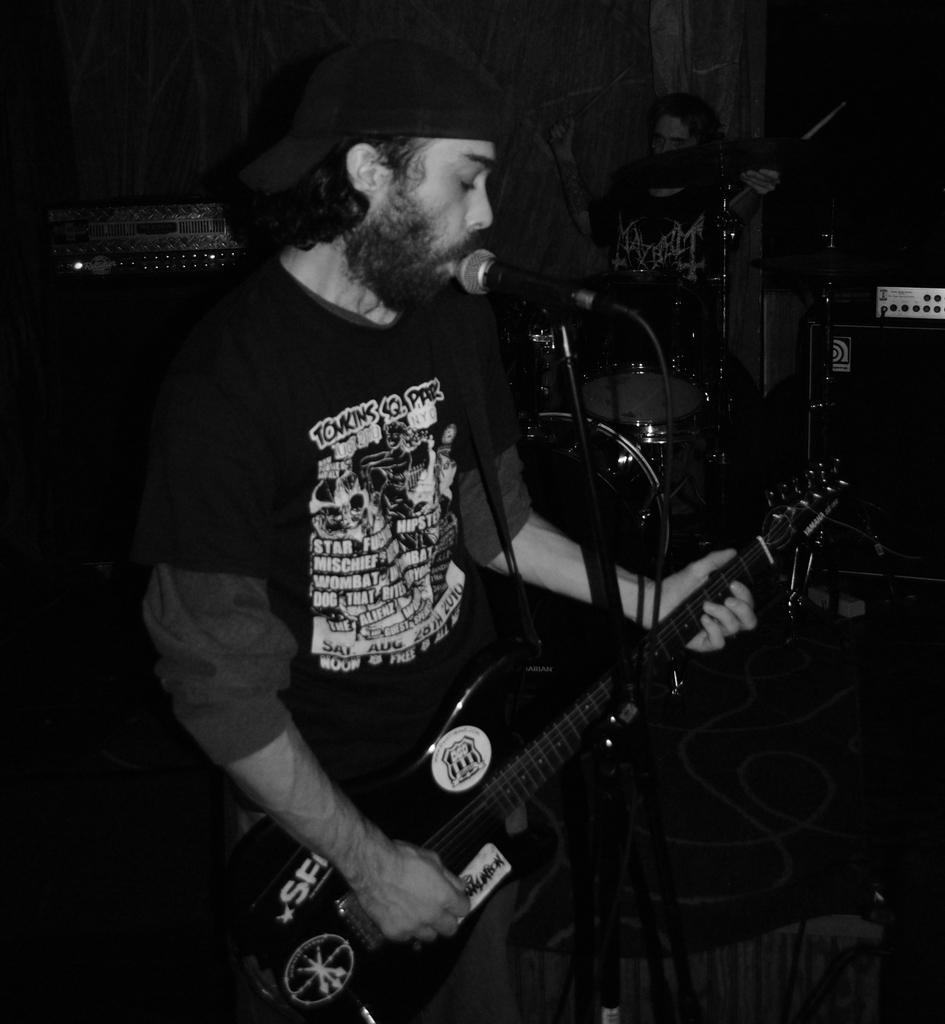What is the man in the image doing? The man is playing a guitar and singing a song. What object is in front of the man? There is a microphone in front of the man. What is the other person in the image doing? The person is playing drums. What language is the man singing in the image? The provided facts do not mention the language of the song being sung, so it cannot be determined from the image. Can you see a basket in the image? There is no basket present in the image. 